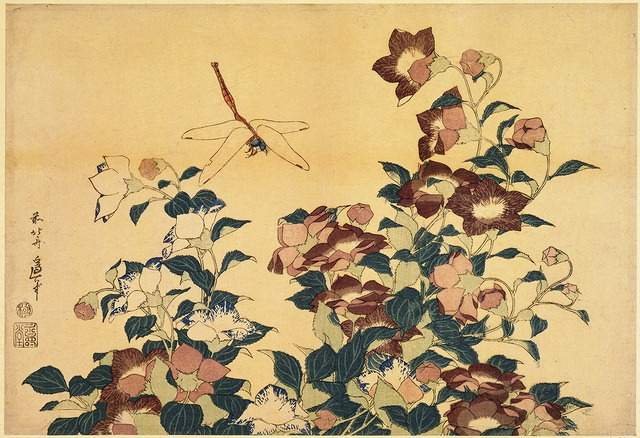What does the dragonfly symbolize in Japanese culture? In Japanese culture, the dragonfly is synonymous with martial success, which is associated with the idea of victory and strength. It is often celebrated in the arts for its grace and agile movements. The appearance of a dragonfly in artworks can also be interpreted as an emblem of new beginnings and summer, reflecting the nature’s transient beauty. 